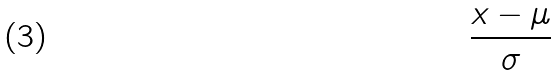<formula> <loc_0><loc_0><loc_500><loc_500>\frac { x - \mu } { \sigma }</formula> 